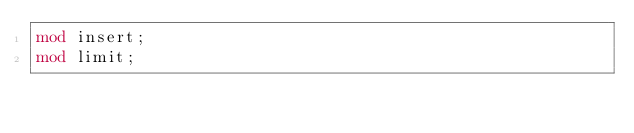<code> <loc_0><loc_0><loc_500><loc_500><_Rust_>mod insert;
mod limit;
</code> 